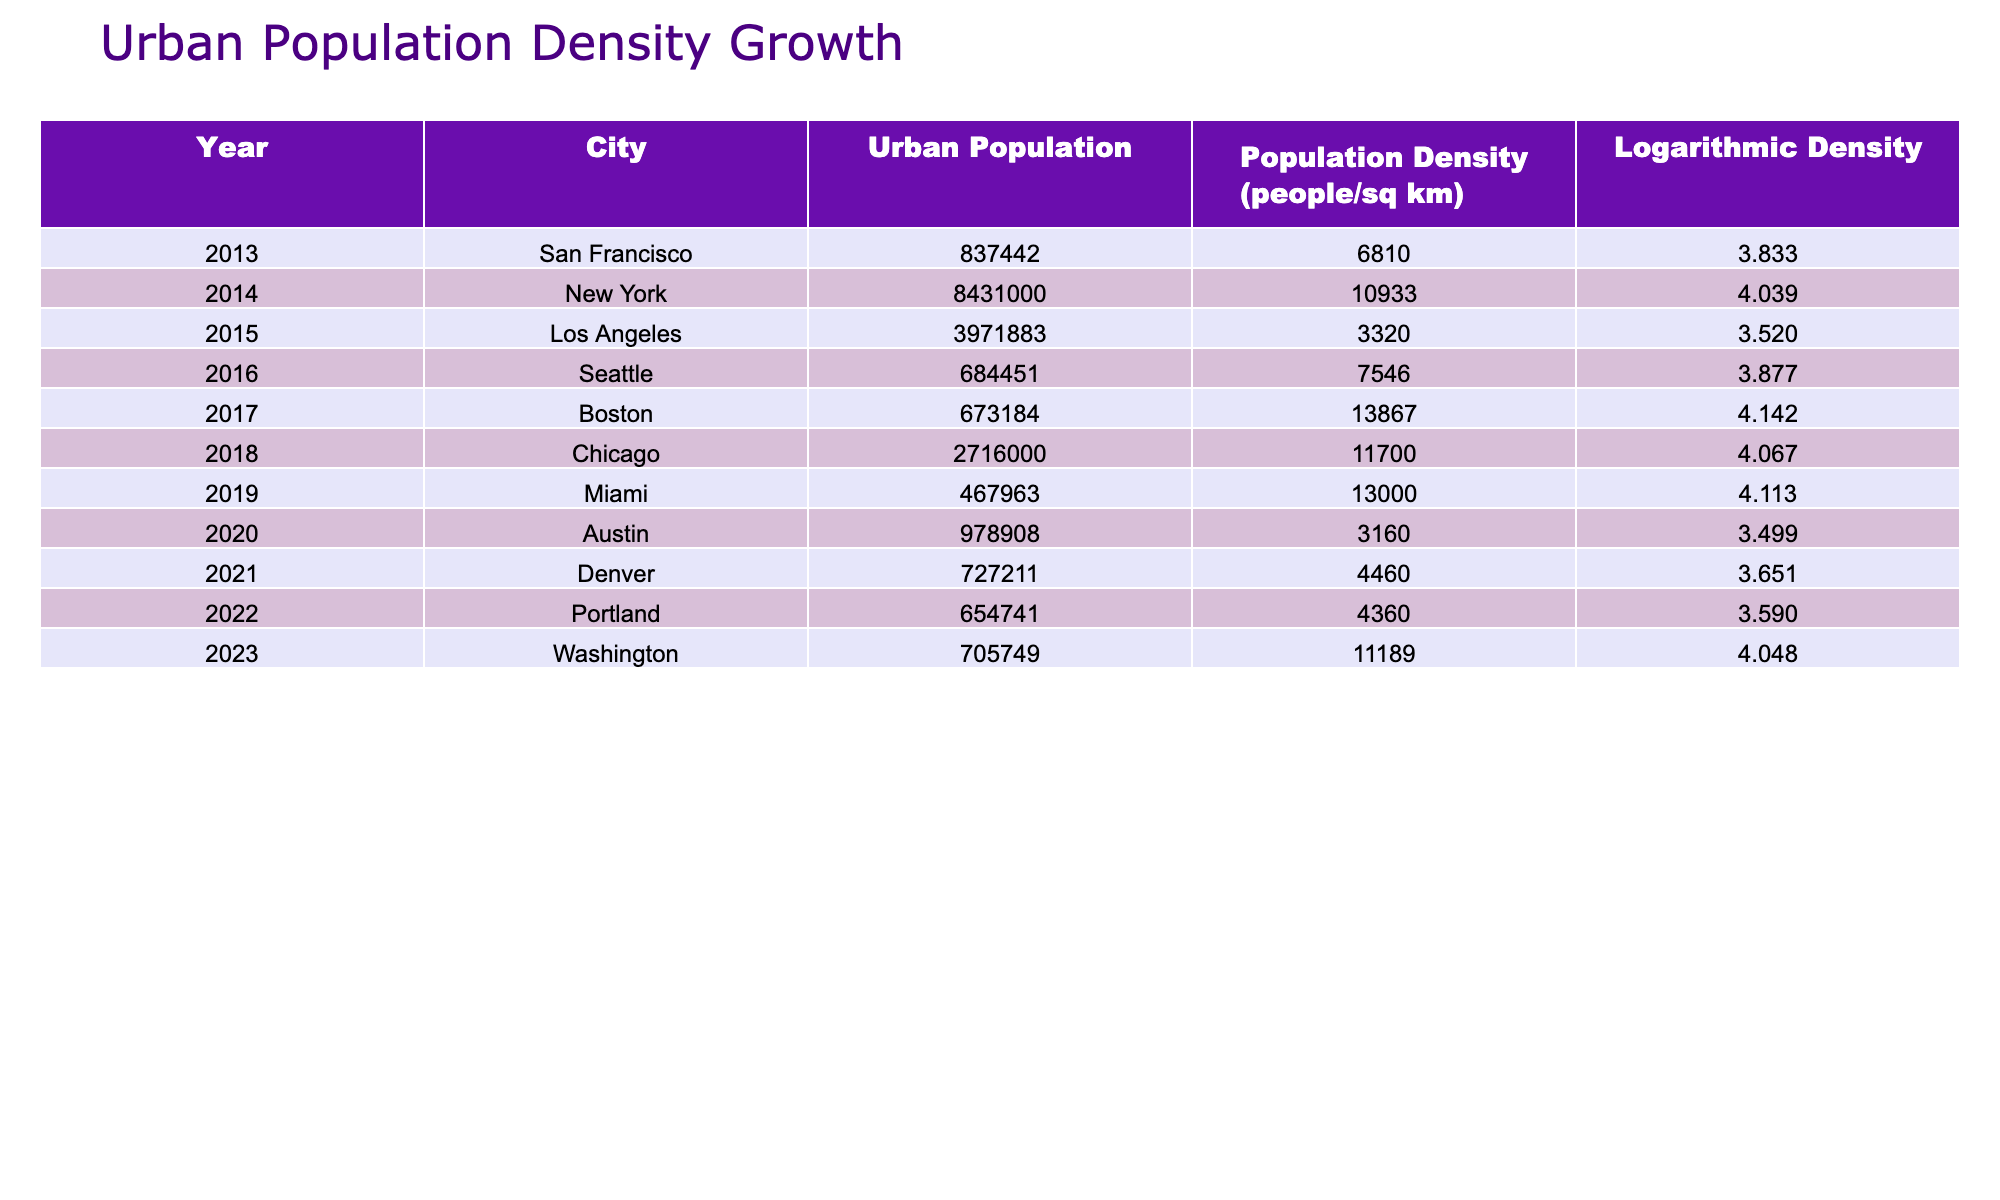What is the urban population of Seattle in 2016? According to the table, the urban population of Seattle in 2016 is directly listed as 684451.
Answer: 684451 Which city has the highest population density in 2017? From the table, Boston has the highest population density in 2017, which is 13867 people/sq km.
Answer: Boston What is the difference in urban population between New York in 2014 and Los Angeles in 2015? The urban population for New York in 2014 is 8431000 and for Los Angeles in 2015 is 3971883. The difference is 8431000 - 3971883 = 4459017.
Answer: 4459017 Is the logarithmic density of Washington in 2023 greater than that of Seattle in 2016? The logarithmic density of Washington in 2023 is 4.048, while for Seattle in 2016 it is 3.877. Since 4.048 is greater than 3.877, the answer is yes.
Answer: Yes What is the average urban population density for the given years? To find the average urban population density, sum up the population densities: 6810 + 10933 + 3320 + 7546 + 13867 + 11700 + 13000 + 3160 + 4460 + 4360 + 11189 = 57145. Then divide by 11 (the number of entries) to get 57145 / 11 = 5195.
Answer: 5195 Which year had the lowest urban population density, and what was the value? The urban population density for Los Angeles in 2015 is 3320, which is the lowest in the table. This can be confirmed by comparing all urban population densities listed.
Answer: 2015, 3320 Do both Portland in 2022 and Austin in 2020 have logarithmic densities below 4? The logarithmic density for Portland in 2022 is 3.590 and for Austin in 2020 is 3.499. Both values are below 4, thus the answer is yes.
Answer: Yes What is the total urban population for all cities listed in 2018? The only urban population value listed for 2018 is Chicago, which is 2716000. Since it is the only entry for that year, the total urban population for this year remains 2716000.
Answer: 2716000 